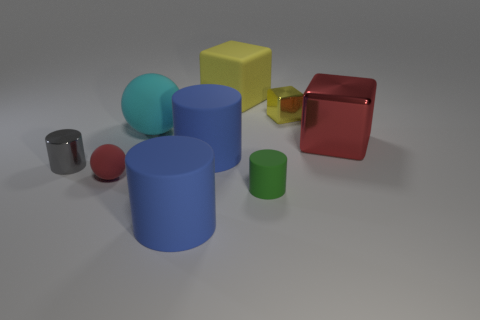What materials are the objects in the image made from? The image depicts various objects with different apparent materials. For example, the yellow and red cubes appear to have a matte finish suggesting a plastic or painted wood material, while the cyan ball seems to be made of rubber due to its sheen. The remaining cylinders and spheres could be interpreted as being made from metals or plastics, differentiated by their glossiness and color. 